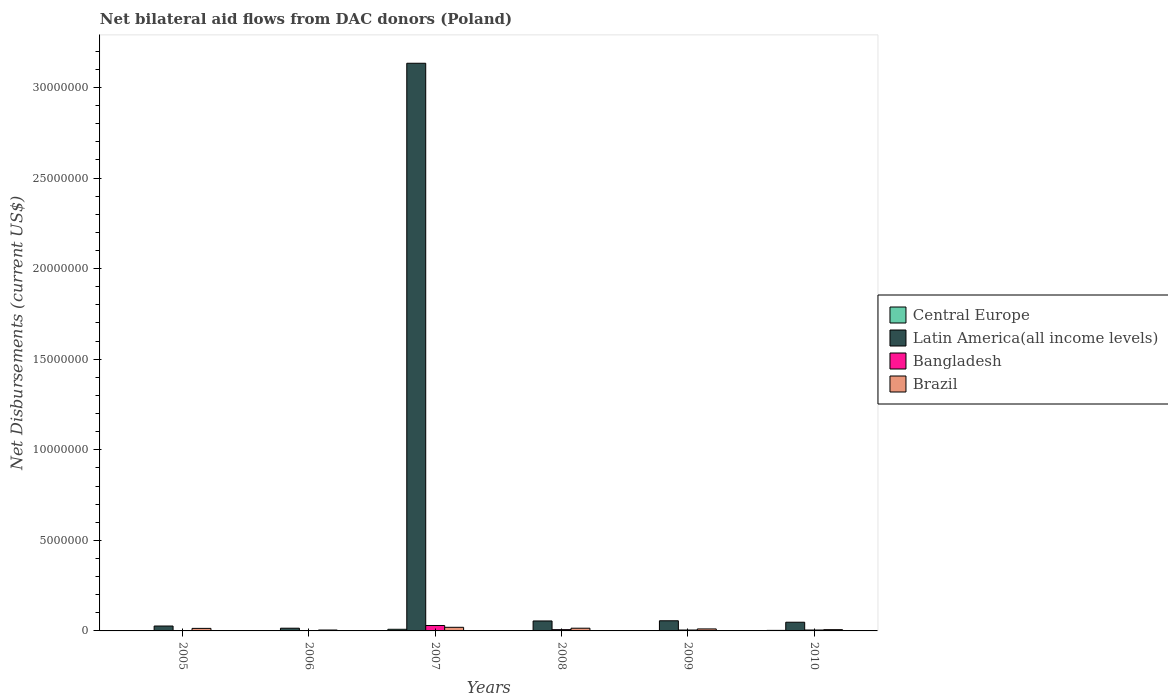How many different coloured bars are there?
Provide a succinct answer. 4. Are the number of bars on each tick of the X-axis equal?
Your answer should be very brief. Yes. How many bars are there on the 1st tick from the right?
Your answer should be very brief. 4. In how many cases, is the number of bars for a given year not equal to the number of legend labels?
Provide a succinct answer. 0. What is the net bilateral aid flows in Brazil in 2010?
Ensure brevity in your answer.  7.00e+04. Across all years, what is the minimum net bilateral aid flows in Latin America(all income levels)?
Offer a very short reply. 1.50e+05. What is the total net bilateral aid flows in Latin America(all income levels) in the graph?
Your answer should be compact. 3.34e+07. What is the difference between the net bilateral aid flows in Brazil in 2006 and that in 2009?
Provide a short and direct response. -6.00e+04. What is the average net bilateral aid flows in Bangladesh per year?
Your answer should be compact. 8.33e+04. In the year 2008, what is the difference between the net bilateral aid flows in Brazil and net bilateral aid flows in Bangladesh?
Offer a terse response. 8.00e+04. What is the ratio of the net bilateral aid flows in Latin America(all income levels) in 2009 to that in 2010?
Your response must be concise. 1.17. Is the net bilateral aid flows in Central Europe in 2007 less than that in 2008?
Ensure brevity in your answer.  No. In how many years, is the net bilateral aid flows in Brazil greater than the average net bilateral aid flows in Brazil taken over all years?
Your answer should be compact. 3. Is it the case that in every year, the sum of the net bilateral aid flows in Latin America(all income levels) and net bilateral aid flows in Bangladesh is greater than the sum of net bilateral aid flows in Brazil and net bilateral aid flows in Central Europe?
Your answer should be compact. Yes. What does the 3rd bar from the right in 2010 represents?
Give a very brief answer. Latin America(all income levels). How many bars are there?
Provide a succinct answer. 24. Are all the bars in the graph horizontal?
Provide a succinct answer. No. Does the graph contain any zero values?
Your answer should be very brief. No. How many legend labels are there?
Provide a short and direct response. 4. How are the legend labels stacked?
Keep it short and to the point. Vertical. What is the title of the graph?
Your response must be concise. Net bilateral aid flows from DAC donors (Poland). Does "Bosnia and Herzegovina" appear as one of the legend labels in the graph?
Make the answer very short. No. What is the label or title of the Y-axis?
Your answer should be very brief. Net Disbursements (current US$). What is the Net Disbursements (current US$) in Central Europe in 2005?
Offer a terse response. 10000. What is the Net Disbursements (current US$) in Latin America(all income levels) in 2005?
Give a very brief answer. 2.70e+05. What is the Net Disbursements (current US$) in Bangladesh in 2005?
Offer a terse response. 10000. What is the Net Disbursements (current US$) of Brazil in 2005?
Offer a very short reply. 1.40e+05. What is the Net Disbursements (current US$) of Central Europe in 2006?
Ensure brevity in your answer.  10000. What is the Net Disbursements (current US$) in Latin America(all income levels) in 2006?
Provide a succinct answer. 1.50e+05. What is the Net Disbursements (current US$) of Latin America(all income levels) in 2007?
Make the answer very short. 3.13e+07. What is the Net Disbursements (current US$) of Brazil in 2007?
Your response must be concise. 2.00e+05. What is the Net Disbursements (current US$) in Latin America(all income levels) in 2008?
Make the answer very short. 5.50e+05. What is the Net Disbursements (current US$) of Brazil in 2008?
Keep it short and to the point. 1.50e+05. What is the Net Disbursements (current US$) in Latin America(all income levels) in 2009?
Keep it short and to the point. 5.60e+05. What is the Net Disbursements (current US$) of Brazil in 2009?
Provide a succinct answer. 1.10e+05. What is the Net Disbursements (current US$) of Latin America(all income levels) in 2010?
Offer a very short reply. 4.80e+05. What is the Net Disbursements (current US$) of Bangladesh in 2010?
Make the answer very short. 5.00e+04. What is the Net Disbursements (current US$) of Brazil in 2010?
Ensure brevity in your answer.  7.00e+04. Across all years, what is the maximum Net Disbursements (current US$) in Latin America(all income levels)?
Your answer should be compact. 3.13e+07. Across all years, what is the minimum Net Disbursements (current US$) of Brazil?
Ensure brevity in your answer.  5.00e+04. What is the total Net Disbursements (current US$) of Latin America(all income levels) in the graph?
Keep it short and to the point. 3.34e+07. What is the total Net Disbursements (current US$) in Brazil in the graph?
Provide a short and direct response. 7.20e+05. What is the difference between the Net Disbursements (current US$) in Central Europe in 2005 and that in 2006?
Offer a very short reply. 0. What is the difference between the Net Disbursements (current US$) of Latin America(all income levels) in 2005 and that in 2006?
Offer a terse response. 1.20e+05. What is the difference between the Net Disbursements (current US$) in Central Europe in 2005 and that in 2007?
Your answer should be very brief. -8.00e+04. What is the difference between the Net Disbursements (current US$) of Latin America(all income levels) in 2005 and that in 2007?
Your answer should be compact. -3.11e+07. What is the difference between the Net Disbursements (current US$) in Central Europe in 2005 and that in 2008?
Provide a short and direct response. -10000. What is the difference between the Net Disbursements (current US$) in Latin America(all income levels) in 2005 and that in 2008?
Keep it short and to the point. -2.80e+05. What is the difference between the Net Disbursements (current US$) in Brazil in 2005 and that in 2008?
Offer a terse response. -10000. What is the difference between the Net Disbursements (current US$) of Brazil in 2005 and that in 2009?
Your answer should be compact. 3.00e+04. What is the difference between the Net Disbursements (current US$) in Central Europe in 2005 and that in 2010?
Provide a short and direct response. -2.00e+04. What is the difference between the Net Disbursements (current US$) in Latin America(all income levels) in 2005 and that in 2010?
Ensure brevity in your answer.  -2.10e+05. What is the difference between the Net Disbursements (current US$) of Latin America(all income levels) in 2006 and that in 2007?
Your answer should be compact. -3.12e+07. What is the difference between the Net Disbursements (current US$) of Bangladesh in 2006 and that in 2007?
Provide a succinct answer. -2.80e+05. What is the difference between the Net Disbursements (current US$) in Latin America(all income levels) in 2006 and that in 2008?
Keep it short and to the point. -4.00e+05. What is the difference between the Net Disbursements (current US$) of Brazil in 2006 and that in 2008?
Ensure brevity in your answer.  -1.00e+05. What is the difference between the Net Disbursements (current US$) of Latin America(all income levels) in 2006 and that in 2009?
Give a very brief answer. -4.10e+05. What is the difference between the Net Disbursements (current US$) of Bangladesh in 2006 and that in 2009?
Give a very brief answer. -3.00e+04. What is the difference between the Net Disbursements (current US$) of Latin America(all income levels) in 2006 and that in 2010?
Give a very brief answer. -3.30e+05. What is the difference between the Net Disbursements (current US$) in Bangladesh in 2006 and that in 2010?
Make the answer very short. -3.00e+04. What is the difference between the Net Disbursements (current US$) of Central Europe in 2007 and that in 2008?
Offer a very short reply. 7.00e+04. What is the difference between the Net Disbursements (current US$) of Latin America(all income levels) in 2007 and that in 2008?
Provide a short and direct response. 3.08e+07. What is the difference between the Net Disbursements (current US$) in Bangladesh in 2007 and that in 2008?
Make the answer very short. 2.30e+05. What is the difference between the Net Disbursements (current US$) of Brazil in 2007 and that in 2008?
Your response must be concise. 5.00e+04. What is the difference between the Net Disbursements (current US$) of Central Europe in 2007 and that in 2009?
Keep it short and to the point. 8.00e+04. What is the difference between the Net Disbursements (current US$) of Latin America(all income levels) in 2007 and that in 2009?
Offer a very short reply. 3.08e+07. What is the difference between the Net Disbursements (current US$) in Brazil in 2007 and that in 2009?
Your answer should be very brief. 9.00e+04. What is the difference between the Net Disbursements (current US$) of Central Europe in 2007 and that in 2010?
Give a very brief answer. 6.00e+04. What is the difference between the Net Disbursements (current US$) of Latin America(all income levels) in 2007 and that in 2010?
Provide a short and direct response. 3.09e+07. What is the difference between the Net Disbursements (current US$) of Bangladesh in 2007 and that in 2010?
Give a very brief answer. 2.50e+05. What is the difference between the Net Disbursements (current US$) in Brazil in 2007 and that in 2010?
Give a very brief answer. 1.30e+05. What is the difference between the Net Disbursements (current US$) in Latin America(all income levels) in 2008 and that in 2009?
Keep it short and to the point. -10000. What is the difference between the Net Disbursements (current US$) in Brazil in 2008 and that in 2009?
Offer a very short reply. 4.00e+04. What is the difference between the Net Disbursements (current US$) in Central Europe in 2008 and that in 2010?
Make the answer very short. -10000. What is the difference between the Net Disbursements (current US$) in Latin America(all income levels) in 2008 and that in 2010?
Your answer should be compact. 7.00e+04. What is the difference between the Net Disbursements (current US$) of Bangladesh in 2008 and that in 2010?
Give a very brief answer. 2.00e+04. What is the difference between the Net Disbursements (current US$) of Latin America(all income levels) in 2009 and that in 2010?
Keep it short and to the point. 8.00e+04. What is the difference between the Net Disbursements (current US$) of Brazil in 2009 and that in 2010?
Offer a terse response. 4.00e+04. What is the difference between the Net Disbursements (current US$) of Central Europe in 2005 and the Net Disbursements (current US$) of Brazil in 2006?
Your answer should be very brief. -4.00e+04. What is the difference between the Net Disbursements (current US$) in Central Europe in 2005 and the Net Disbursements (current US$) in Latin America(all income levels) in 2007?
Your answer should be compact. -3.13e+07. What is the difference between the Net Disbursements (current US$) of Latin America(all income levels) in 2005 and the Net Disbursements (current US$) of Bangladesh in 2007?
Your answer should be very brief. -3.00e+04. What is the difference between the Net Disbursements (current US$) in Bangladesh in 2005 and the Net Disbursements (current US$) in Brazil in 2007?
Provide a short and direct response. -1.90e+05. What is the difference between the Net Disbursements (current US$) of Central Europe in 2005 and the Net Disbursements (current US$) of Latin America(all income levels) in 2008?
Your answer should be very brief. -5.40e+05. What is the difference between the Net Disbursements (current US$) of Central Europe in 2005 and the Net Disbursements (current US$) of Bangladesh in 2008?
Offer a very short reply. -6.00e+04. What is the difference between the Net Disbursements (current US$) in Central Europe in 2005 and the Net Disbursements (current US$) in Brazil in 2008?
Offer a terse response. -1.40e+05. What is the difference between the Net Disbursements (current US$) in Latin America(all income levels) in 2005 and the Net Disbursements (current US$) in Bangladesh in 2008?
Your answer should be compact. 2.00e+05. What is the difference between the Net Disbursements (current US$) in Latin America(all income levels) in 2005 and the Net Disbursements (current US$) in Brazil in 2008?
Your answer should be compact. 1.20e+05. What is the difference between the Net Disbursements (current US$) of Bangladesh in 2005 and the Net Disbursements (current US$) of Brazil in 2008?
Keep it short and to the point. -1.40e+05. What is the difference between the Net Disbursements (current US$) in Central Europe in 2005 and the Net Disbursements (current US$) in Latin America(all income levels) in 2009?
Offer a very short reply. -5.50e+05. What is the difference between the Net Disbursements (current US$) in Central Europe in 2005 and the Net Disbursements (current US$) in Brazil in 2009?
Ensure brevity in your answer.  -1.00e+05. What is the difference between the Net Disbursements (current US$) in Latin America(all income levels) in 2005 and the Net Disbursements (current US$) in Brazil in 2009?
Your response must be concise. 1.60e+05. What is the difference between the Net Disbursements (current US$) of Bangladesh in 2005 and the Net Disbursements (current US$) of Brazil in 2009?
Your answer should be compact. -1.00e+05. What is the difference between the Net Disbursements (current US$) in Central Europe in 2005 and the Net Disbursements (current US$) in Latin America(all income levels) in 2010?
Make the answer very short. -4.70e+05. What is the difference between the Net Disbursements (current US$) of Latin America(all income levels) in 2005 and the Net Disbursements (current US$) of Bangladesh in 2010?
Your response must be concise. 2.20e+05. What is the difference between the Net Disbursements (current US$) in Central Europe in 2006 and the Net Disbursements (current US$) in Latin America(all income levels) in 2007?
Provide a short and direct response. -3.13e+07. What is the difference between the Net Disbursements (current US$) of Latin America(all income levels) in 2006 and the Net Disbursements (current US$) of Brazil in 2007?
Your answer should be compact. -5.00e+04. What is the difference between the Net Disbursements (current US$) in Bangladesh in 2006 and the Net Disbursements (current US$) in Brazil in 2007?
Provide a short and direct response. -1.80e+05. What is the difference between the Net Disbursements (current US$) of Central Europe in 2006 and the Net Disbursements (current US$) of Latin America(all income levels) in 2008?
Give a very brief answer. -5.40e+05. What is the difference between the Net Disbursements (current US$) of Bangladesh in 2006 and the Net Disbursements (current US$) of Brazil in 2008?
Give a very brief answer. -1.30e+05. What is the difference between the Net Disbursements (current US$) in Central Europe in 2006 and the Net Disbursements (current US$) in Latin America(all income levels) in 2009?
Provide a short and direct response. -5.50e+05. What is the difference between the Net Disbursements (current US$) of Central Europe in 2006 and the Net Disbursements (current US$) of Latin America(all income levels) in 2010?
Provide a succinct answer. -4.70e+05. What is the difference between the Net Disbursements (current US$) in Latin America(all income levels) in 2006 and the Net Disbursements (current US$) in Brazil in 2010?
Provide a succinct answer. 8.00e+04. What is the difference between the Net Disbursements (current US$) in Bangladesh in 2006 and the Net Disbursements (current US$) in Brazil in 2010?
Ensure brevity in your answer.  -5.00e+04. What is the difference between the Net Disbursements (current US$) of Central Europe in 2007 and the Net Disbursements (current US$) of Latin America(all income levels) in 2008?
Your answer should be very brief. -4.60e+05. What is the difference between the Net Disbursements (current US$) of Latin America(all income levels) in 2007 and the Net Disbursements (current US$) of Bangladesh in 2008?
Your answer should be compact. 3.13e+07. What is the difference between the Net Disbursements (current US$) of Latin America(all income levels) in 2007 and the Net Disbursements (current US$) of Brazil in 2008?
Offer a very short reply. 3.12e+07. What is the difference between the Net Disbursements (current US$) in Central Europe in 2007 and the Net Disbursements (current US$) in Latin America(all income levels) in 2009?
Keep it short and to the point. -4.70e+05. What is the difference between the Net Disbursements (current US$) in Central Europe in 2007 and the Net Disbursements (current US$) in Brazil in 2009?
Ensure brevity in your answer.  -2.00e+04. What is the difference between the Net Disbursements (current US$) of Latin America(all income levels) in 2007 and the Net Disbursements (current US$) of Bangladesh in 2009?
Your response must be concise. 3.13e+07. What is the difference between the Net Disbursements (current US$) of Latin America(all income levels) in 2007 and the Net Disbursements (current US$) of Brazil in 2009?
Your response must be concise. 3.12e+07. What is the difference between the Net Disbursements (current US$) in Central Europe in 2007 and the Net Disbursements (current US$) in Latin America(all income levels) in 2010?
Keep it short and to the point. -3.90e+05. What is the difference between the Net Disbursements (current US$) in Latin America(all income levels) in 2007 and the Net Disbursements (current US$) in Bangladesh in 2010?
Offer a terse response. 3.13e+07. What is the difference between the Net Disbursements (current US$) of Latin America(all income levels) in 2007 and the Net Disbursements (current US$) of Brazil in 2010?
Your response must be concise. 3.13e+07. What is the difference between the Net Disbursements (current US$) of Central Europe in 2008 and the Net Disbursements (current US$) of Latin America(all income levels) in 2009?
Offer a very short reply. -5.40e+05. What is the difference between the Net Disbursements (current US$) of Central Europe in 2008 and the Net Disbursements (current US$) of Bangladesh in 2009?
Provide a short and direct response. -3.00e+04. What is the difference between the Net Disbursements (current US$) of Central Europe in 2008 and the Net Disbursements (current US$) of Brazil in 2009?
Your answer should be very brief. -9.00e+04. What is the difference between the Net Disbursements (current US$) in Latin America(all income levels) in 2008 and the Net Disbursements (current US$) in Bangladesh in 2009?
Provide a succinct answer. 5.00e+05. What is the difference between the Net Disbursements (current US$) in Central Europe in 2008 and the Net Disbursements (current US$) in Latin America(all income levels) in 2010?
Ensure brevity in your answer.  -4.60e+05. What is the difference between the Net Disbursements (current US$) of Latin America(all income levels) in 2008 and the Net Disbursements (current US$) of Bangladesh in 2010?
Your answer should be very brief. 5.00e+05. What is the difference between the Net Disbursements (current US$) of Latin America(all income levels) in 2008 and the Net Disbursements (current US$) of Brazil in 2010?
Provide a short and direct response. 4.80e+05. What is the difference between the Net Disbursements (current US$) of Bangladesh in 2008 and the Net Disbursements (current US$) of Brazil in 2010?
Keep it short and to the point. 0. What is the difference between the Net Disbursements (current US$) of Central Europe in 2009 and the Net Disbursements (current US$) of Latin America(all income levels) in 2010?
Provide a short and direct response. -4.70e+05. What is the difference between the Net Disbursements (current US$) in Central Europe in 2009 and the Net Disbursements (current US$) in Bangladesh in 2010?
Make the answer very short. -4.00e+04. What is the difference between the Net Disbursements (current US$) of Central Europe in 2009 and the Net Disbursements (current US$) of Brazil in 2010?
Make the answer very short. -6.00e+04. What is the difference between the Net Disbursements (current US$) of Latin America(all income levels) in 2009 and the Net Disbursements (current US$) of Bangladesh in 2010?
Give a very brief answer. 5.10e+05. What is the difference between the Net Disbursements (current US$) in Latin America(all income levels) in 2009 and the Net Disbursements (current US$) in Brazil in 2010?
Provide a succinct answer. 4.90e+05. What is the difference between the Net Disbursements (current US$) of Bangladesh in 2009 and the Net Disbursements (current US$) of Brazil in 2010?
Your answer should be compact. -2.00e+04. What is the average Net Disbursements (current US$) of Central Europe per year?
Offer a terse response. 2.83e+04. What is the average Net Disbursements (current US$) of Latin America(all income levels) per year?
Your answer should be compact. 5.56e+06. What is the average Net Disbursements (current US$) of Bangladesh per year?
Keep it short and to the point. 8.33e+04. In the year 2005, what is the difference between the Net Disbursements (current US$) of Central Europe and Net Disbursements (current US$) of Latin America(all income levels)?
Your answer should be very brief. -2.60e+05. In the year 2005, what is the difference between the Net Disbursements (current US$) of Central Europe and Net Disbursements (current US$) of Brazil?
Give a very brief answer. -1.30e+05. In the year 2006, what is the difference between the Net Disbursements (current US$) of Central Europe and Net Disbursements (current US$) of Bangladesh?
Ensure brevity in your answer.  -10000. In the year 2006, what is the difference between the Net Disbursements (current US$) in Latin America(all income levels) and Net Disbursements (current US$) in Bangladesh?
Offer a terse response. 1.30e+05. In the year 2006, what is the difference between the Net Disbursements (current US$) of Latin America(all income levels) and Net Disbursements (current US$) of Brazil?
Your answer should be very brief. 1.00e+05. In the year 2007, what is the difference between the Net Disbursements (current US$) in Central Europe and Net Disbursements (current US$) in Latin America(all income levels)?
Give a very brief answer. -3.12e+07. In the year 2007, what is the difference between the Net Disbursements (current US$) in Central Europe and Net Disbursements (current US$) in Brazil?
Your answer should be very brief. -1.10e+05. In the year 2007, what is the difference between the Net Disbursements (current US$) in Latin America(all income levels) and Net Disbursements (current US$) in Bangladesh?
Your answer should be very brief. 3.10e+07. In the year 2007, what is the difference between the Net Disbursements (current US$) of Latin America(all income levels) and Net Disbursements (current US$) of Brazil?
Provide a succinct answer. 3.11e+07. In the year 2008, what is the difference between the Net Disbursements (current US$) of Central Europe and Net Disbursements (current US$) of Latin America(all income levels)?
Keep it short and to the point. -5.30e+05. In the year 2008, what is the difference between the Net Disbursements (current US$) in Central Europe and Net Disbursements (current US$) in Bangladesh?
Offer a very short reply. -5.00e+04. In the year 2009, what is the difference between the Net Disbursements (current US$) in Central Europe and Net Disbursements (current US$) in Latin America(all income levels)?
Your answer should be compact. -5.50e+05. In the year 2009, what is the difference between the Net Disbursements (current US$) of Central Europe and Net Disbursements (current US$) of Bangladesh?
Your answer should be compact. -4.00e+04. In the year 2009, what is the difference between the Net Disbursements (current US$) in Latin America(all income levels) and Net Disbursements (current US$) in Bangladesh?
Make the answer very short. 5.10e+05. In the year 2009, what is the difference between the Net Disbursements (current US$) of Bangladesh and Net Disbursements (current US$) of Brazil?
Offer a terse response. -6.00e+04. In the year 2010, what is the difference between the Net Disbursements (current US$) of Central Europe and Net Disbursements (current US$) of Latin America(all income levels)?
Give a very brief answer. -4.50e+05. In the year 2010, what is the difference between the Net Disbursements (current US$) in Latin America(all income levels) and Net Disbursements (current US$) in Bangladesh?
Keep it short and to the point. 4.30e+05. In the year 2010, what is the difference between the Net Disbursements (current US$) of Latin America(all income levels) and Net Disbursements (current US$) of Brazil?
Your answer should be very brief. 4.10e+05. In the year 2010, what is the difference between the Net Disbursements (current US$) of Bangladesh and Net Disbursements (current US$) of Brazil?
Your response must be concise. -2.00e+04. What is the ratio of the Net Disbursements (current US$) in Central Europe in 2005 to that in 2006?
Give a very brief answer. 1. What is the ratio of the Net Disbursements (current US$) of Latin America(all income levels) in 2005 to that in 2006?
Your response must be concise. 1.8. What is the ratio of the Net Disbursements (current US$) of Bangladesh in 2005 to that in 2006?
Provide a short and direct response. 0.5. What is the ratio of the Net Disbursements (current US$) of Latin America(all income levels) in 2005 to that in 2007?
Provide a short and direct response. 0.01. What is the ratio of the Net Disbursements (current US$) in Bangladesh in 2005 to that in 2007?
Provide a short and direct response. 0.03. What is the ratio of the Net Disbursements (current US$) of Brazil in 2005 to that in 2007?
Your answer should be compact. 0.7. What is the ratio of the Net Disbursements (current US$) of Central Europe in 2005 to that in 2008?
Give a very brief answer. 0.5. What is the ratio of the Net Disbursements (current US$) of Latin America(all income levels) in 2005 to that in 2008?
Your answer should be very brief. 0.49. What is the ratio of the Net Disbursements (current US$) of Bangladesh in 2005 to that in 2008?
Give a very brief answer. 0.14. What is the ratio of the Net Disbursements (current US$) of Central Europe in 2005 to that in 2009?
Provide a short and direct response. 1. What is the ratio of the Net Disbursements (current US$) in Latin America(all income levels) in 2005 to that in 2009?
Your response must be concise. 0.48. What is the ratio of the Net Disbursements (current US$) in Brazil in 2005 to that in 2009?
Your answer should be compact. 1.27. What is the ratio of the Net Disbursements (current US$) in Central Europe in 2005 to that in 2010?
Provide a short and direct response. 0.33. What is the ratio of the Net Disbursements (current US$) of Latin America(all income levels) in 2005 to that in 2010?
Ensure brevity in your answer.  0.56. What is the ratio of the Net Disbursements (current US$) of Brazil in 2005 to that in 2010?
Your answer should be compact. 2. What is the ratio of the Net Disbursements (current US$) in Latin America(all income levels) in 2006 to that in 2007?
Your response must be concise. 0. What is the ratio of the Net Disbursements (current US$) in Bangladesh in 2006 to that in 2007?
Provide a succinct answer. 0.07. What is the ratio of the Net Disbursements (current US$) in Central Europe in 2006 to that in 2008?
Offer a very short reply. 0.5. What is the ratio of the Net Disbursements (current US$) in Latin America(all income levels) in 2006 to that in 2008?
Keep it short and to the point. 0.27. What is the ratio of the Net Disbursements (current US$) in Bangladesh in 2006 to that in 2008?
Your response must be concise. 0.29. What is the ratio of the Net Disbursements (current US$) of Central Europe in 2006 to that in 2009?
Your answer should be compact. 1. What is the ratio of the Net Disbursements (current US$) in Latin America(all income levels) in 2006 to that in 2009?
Make the answer very short. 0.27. What is the ratio of the Net Disbursements (current US$) in Bangladesh in 2006 to that in 2009?
Offer a terse response. 0.4. What is the ratio of the Net Disbursements (current US$) in Brazil in 2006 to that in 2009?
Your answer should be compact. 0.45. What is the ratio of the Net Disbursements (current US$) in Latin America(all income levels) in 2006 to that in 2010?
Keep it short and to the point. 0.31. What is the ratio of the Net Disbursements (current US$) of Bangladesh in 2006 to that in 2010?
Your response must be concise. 0.4. What is the ratio of the Net Disbursements (current US$) of Latin America(all income levels) in 2007 to that in 2008?
Your response must be concise. 56.98. What is the ratio of the Net Disbursements (current US$) in Bangladesh in 2007 to that in 2008?
Your response must be concise. 4.29. What is the ratio of the Net Disbursements (current US$) of Central Europe in 2007 to that in 2009?
Make the answer very short. 9. What is the ratio of the Net Disbursements (current US$) of Latin America(all income levels) in 2007 to that in 2009?
Offer a terse response. 55.96. What is the ratio of the Net Disbursements (current US$) of Bangladesh in 2007 to that in 2009?
Make the answer very short. 6. What is the ratio of the Net Disbursements (current US$) of Brazil in 2007 to that in 2009?
Your response must be concise. 1.82. What is the ratio of the Net Disbursements (current US$) of Latin America(all income levels) in 2007 to that in 2010?
Your answer should be compact. 65.29. What is the ratio of the Net Disbursements (current US$) of Brazil in 2007 to that in 2010?
Provide a succinct answer. 2.86. What is the ratio of the Net Disbursements (current US$) in Central Europe in 2008 to that in 2009?
Offer a terse response. 2. What is the ratio of the Net Disbursements (current US$) in Latin America(all income levels) in 2008 to that in 2009?
Ensure brevity in your answer.  0.98. What is the ratio of the Net Disbursements (current US$) of Brazil in 2008 to that in 2009?
Your answer should be compact. 1.36. What is the ratio of the Net Disbursements (current US$) of Latin America(all income levels) in 2008 to that in 2010?
Provide a succinct answer. 1.15. What is the ratio of the Net Disbursements (current US$) of Brazil in 2008 to that in 2010?
Your response must be concise. 2.14. What is the ratio of the Net Disbursements (current US$) in Central Europe in 2009 to that in 2010?
Provide a short and direct response. 0.33. What is the ratio of the Net Disbursements (current US$) in Brazil in 2009 to that in 2010?
Your answer should be very brief. 1.57. What is the difference between the highest and the second highest Net Disbursements (current US$) of Latin America(all income levels)?
Your answer should be very brief. 3.08e+07. What is the difference between the highest and the lowest Net Disbursements (current US$) in Latin America(all income levels)?
Offer a very short reply. 3.12e+07. What is the difference between the highest and the lowest Net Disbursements (current US$) in Bangladesh?
Offer a terse response. 2.90e+05. What is the difference between the highest and the lowest Net Disbursements (current US$) in Brazil?
Offer a very short reply. 1.50e+05. 